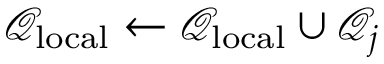<formula> <loc_0><loc_0><loc_500><loc_500>\mathcal { Q } _ { l o c a l } \leftarrow \mathcal { Q } _ { l o c a l } \cup \mathcal { Q } _ { j }</formula> 